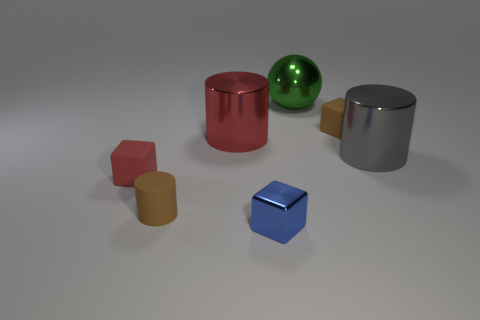Add 1 blue matte objects. How many objects exist? 8 Subtract all balls. How many objects are left? 6 Add 5 gray shiny cylinders. How many gray shiny cylinders exist? 6 Subtract 0 purple spheres. How many objects are left? 7 Subtract all yellow metal cylinders. Subtract all red rubber things. How many objects are left? 6 Add 7 small blue things. How many small blue things are left? 8 